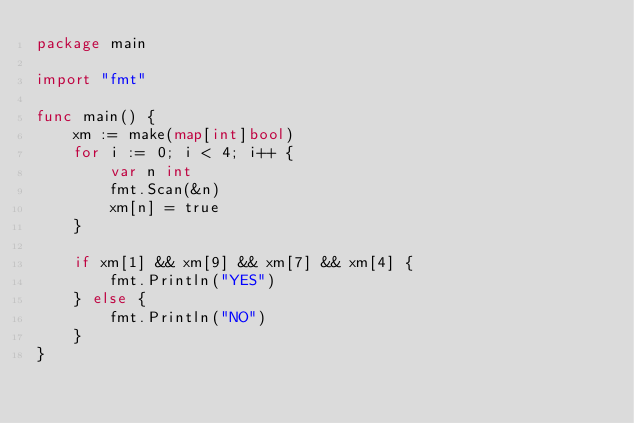<code> <loc_0><loc_0><loc_500><loc_500><_Go_>package main

import "fmt"

func main() {
	xm := make(map[int]bool)
	for i := 0; i < 4; i++ {
		var n int
		fmt.Scan(&n)
		xm[n] = true
	}

	if xm[1] && xm[9] && xm[7] && xm[4] {
		fmt.Println("YES")
	} else {
		fmt.Println("NO")
	}
}
</code> 